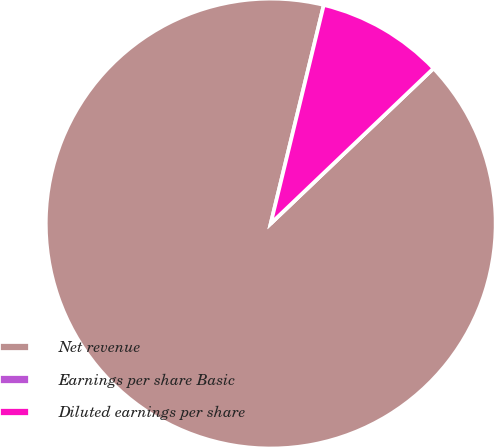Convert chart to OTSL. <chart><loc_0><loc_0><loc_500><loc_500><pie_chart><fcel>Net revenue<fcel>Earnings per share Basic<fcel>Diluted earnings per share<nl><fcel>90.91%<fcel>0.0%<fcel>9.09%<nl></chart> 